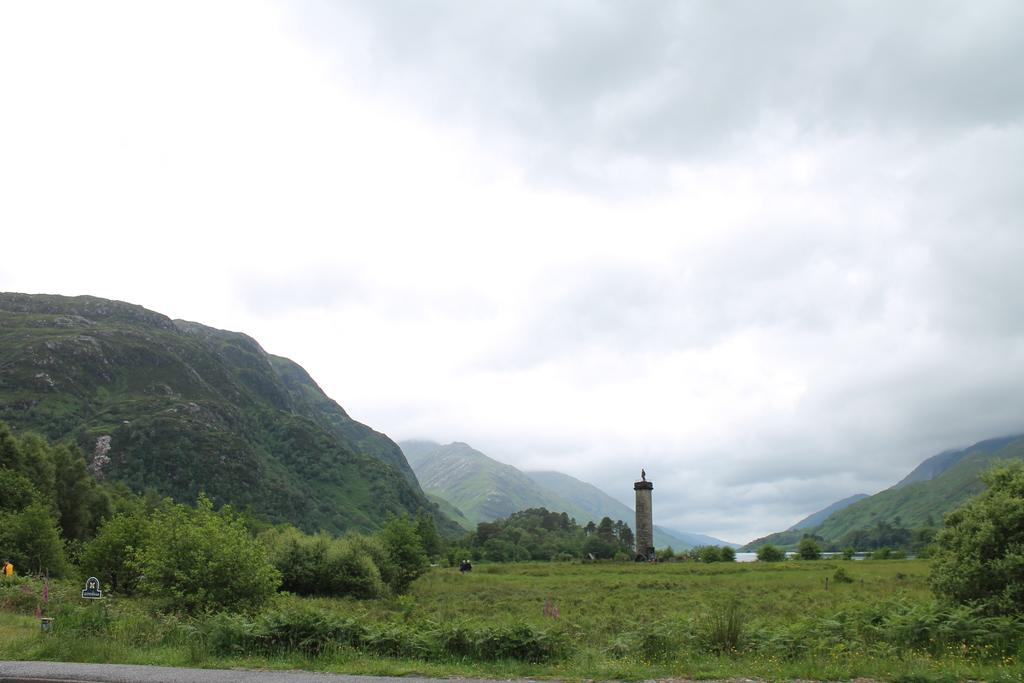What type of natural landform is present in the image? The image contains mountains. What is visible at the bottom of the image? There is green grass and plants at the bottom of the image. What structure can be seen in the middle of the image? There appears to be a lighthouse in the middle of the image. What is visible at the top of the image? The sky is visible at the top of the image. What can be seen in the sky in the image? There are clouds in the sky. How many geese are visible in the image? There are no geese present in the image. What type of animal can be seen grazing in the green grass at the bottom of the image? There is no animal visible in the green grass at the bottom of the image. 